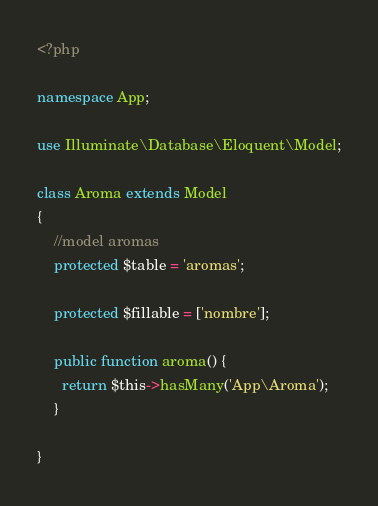Convert code to text. <code><loc_0><loc_0><loc_500><loc_500><_PHP_><?php

namespace App;

use Illuminate\Database\Eloquent\Model;

class Aroma extends Model
{
    //model aromas
    protected $table = 'aromas';

    protected $fillable = ['nombre'];

    public function aroma() {
      return $this->hasMany('App\Aroma');
    }

}
</code> 